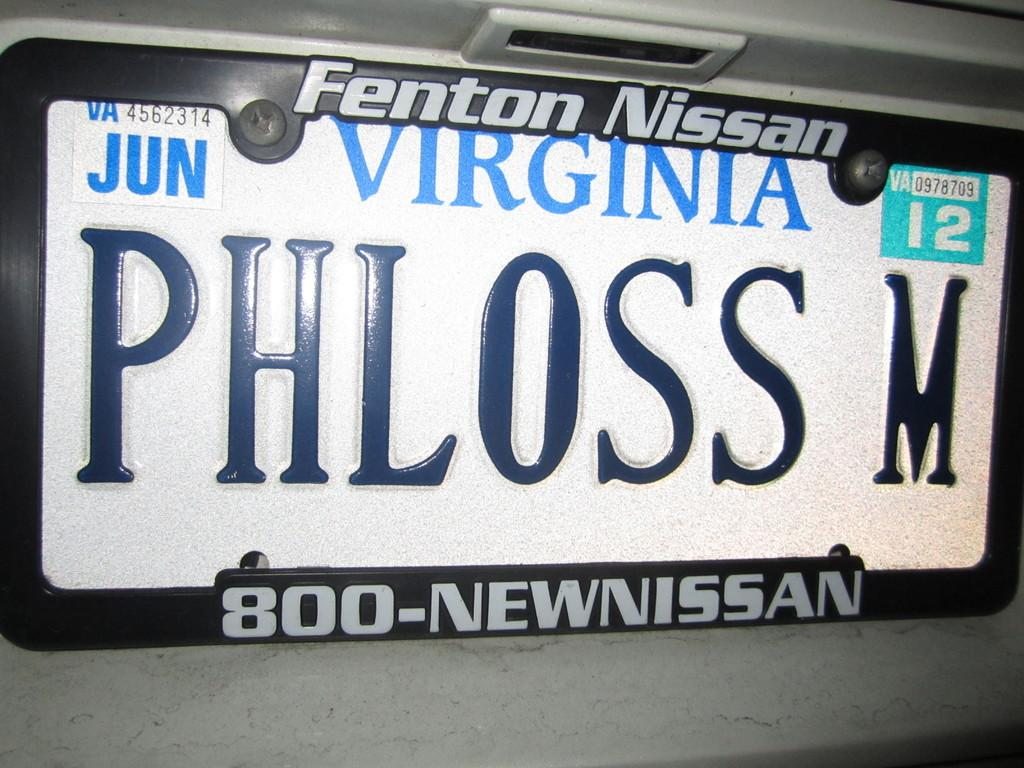<image>
Offer a succinct explanation of the picture presented. The Virginia license plate says PHLOSS M and is on  Nissan 